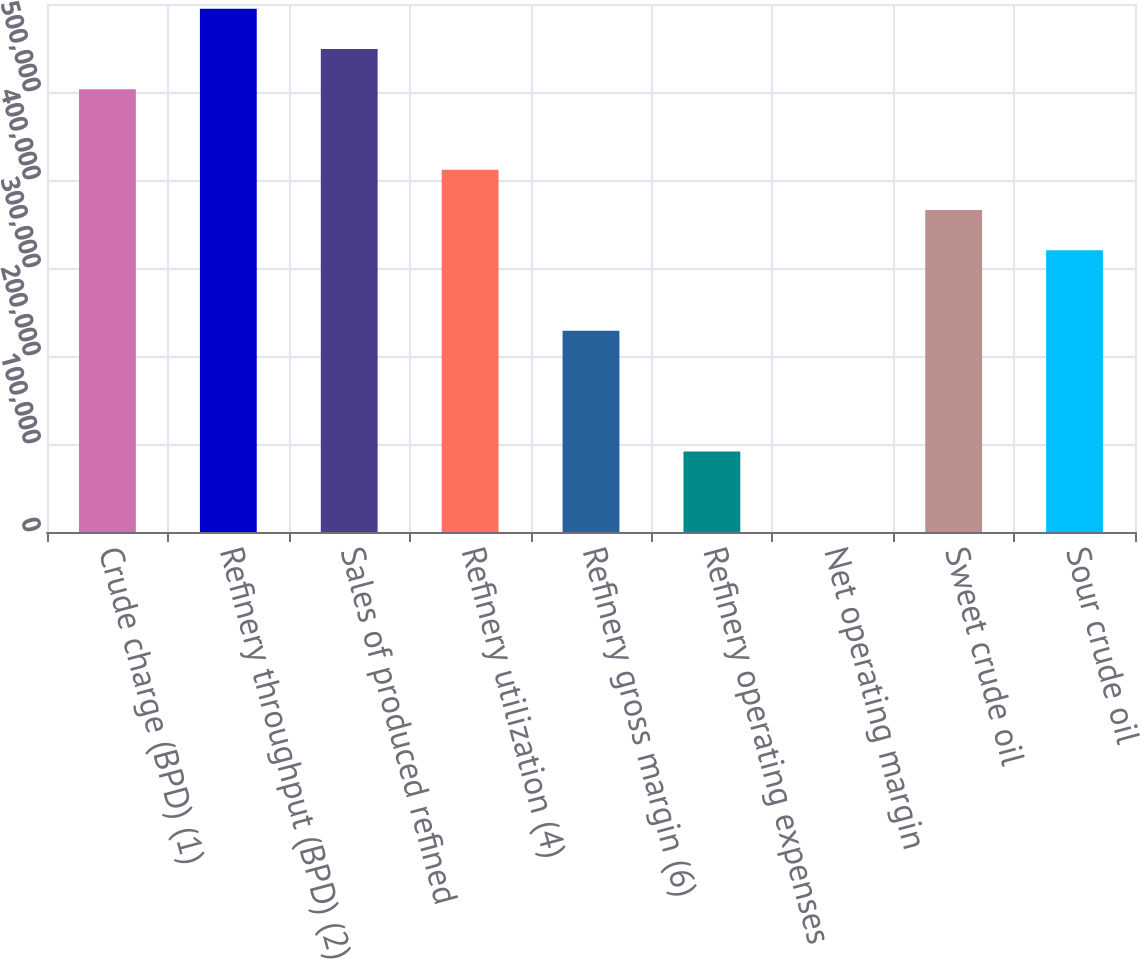Convert chart to OTSL. <chart><loc_0><loc_0><loc_500><loc_500><bar_chart><fcel>Crude charge (BPD) (1)<fcel>Refinery throughput (BPD) (2)<fcel>Sales of produced refined<fcel>Refinery utilization (4)<fcel>Refinery gross margin (6)<fcel>Refinery operating expenses<fcel>Net operating margin<fcel>Sweet crude oil<fcel>Sour crude oil<nl><fcel>503228<fcel>594723<fcel>548976<fcel>411732<fcel>228741<fcel>91498<fcel>2.51<fcel>365985<fcel>320237<nl></chart> 